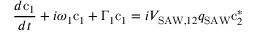<formula> <loc_0><loc_0><loc_500><loc_500>\frac { d c _ { 1 } } { d t } + i \omega _ { 1 } c _ { 1 } + \Gamma _ { 1 } c _ { 1 } = i V _ { S A W , 1 2 } q _ { S A W } c _ { 2 } ^ { * }</formula> 